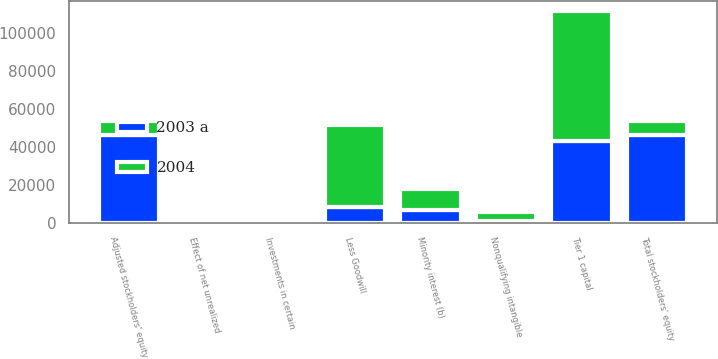Convert chart. <chart><loc_0><loc_0><loc_500><loc_500><stacked_bar_chart><ecel><fcel>Total stockholders' equity<fcel>Effect of net unrealized<fcel>Adjusted stockholders' equity<fcel>Minority interest (b)<fcel>Less Goodwill<fcel>Investments in certain<fcel>Nonqualifying intangible<fcel>Tier 1 capital<nl><fcel>2004<fcel>7696.5<fcel>200<fcel>7696.5<fcel>11050<fcel>43203<fcel>370<fcel>4709<fcel>68621<nl><fcel>2003 a<fcel>46154<fcel>24<fcel>46178<fcel>6882<fcel>8511<fcel>266<fcel>1116<fcel>43167<nl></chart> 